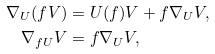Convert formula to latex. <formula><loc_0><loc_0><loc_500><loc_500>\nabla _ { U } ( f V ) & = U ( f ) V + f \nabla _ { U } V , \\ \nabla _ { f U } V & = f \nabla _ { U } V ,</formula> 